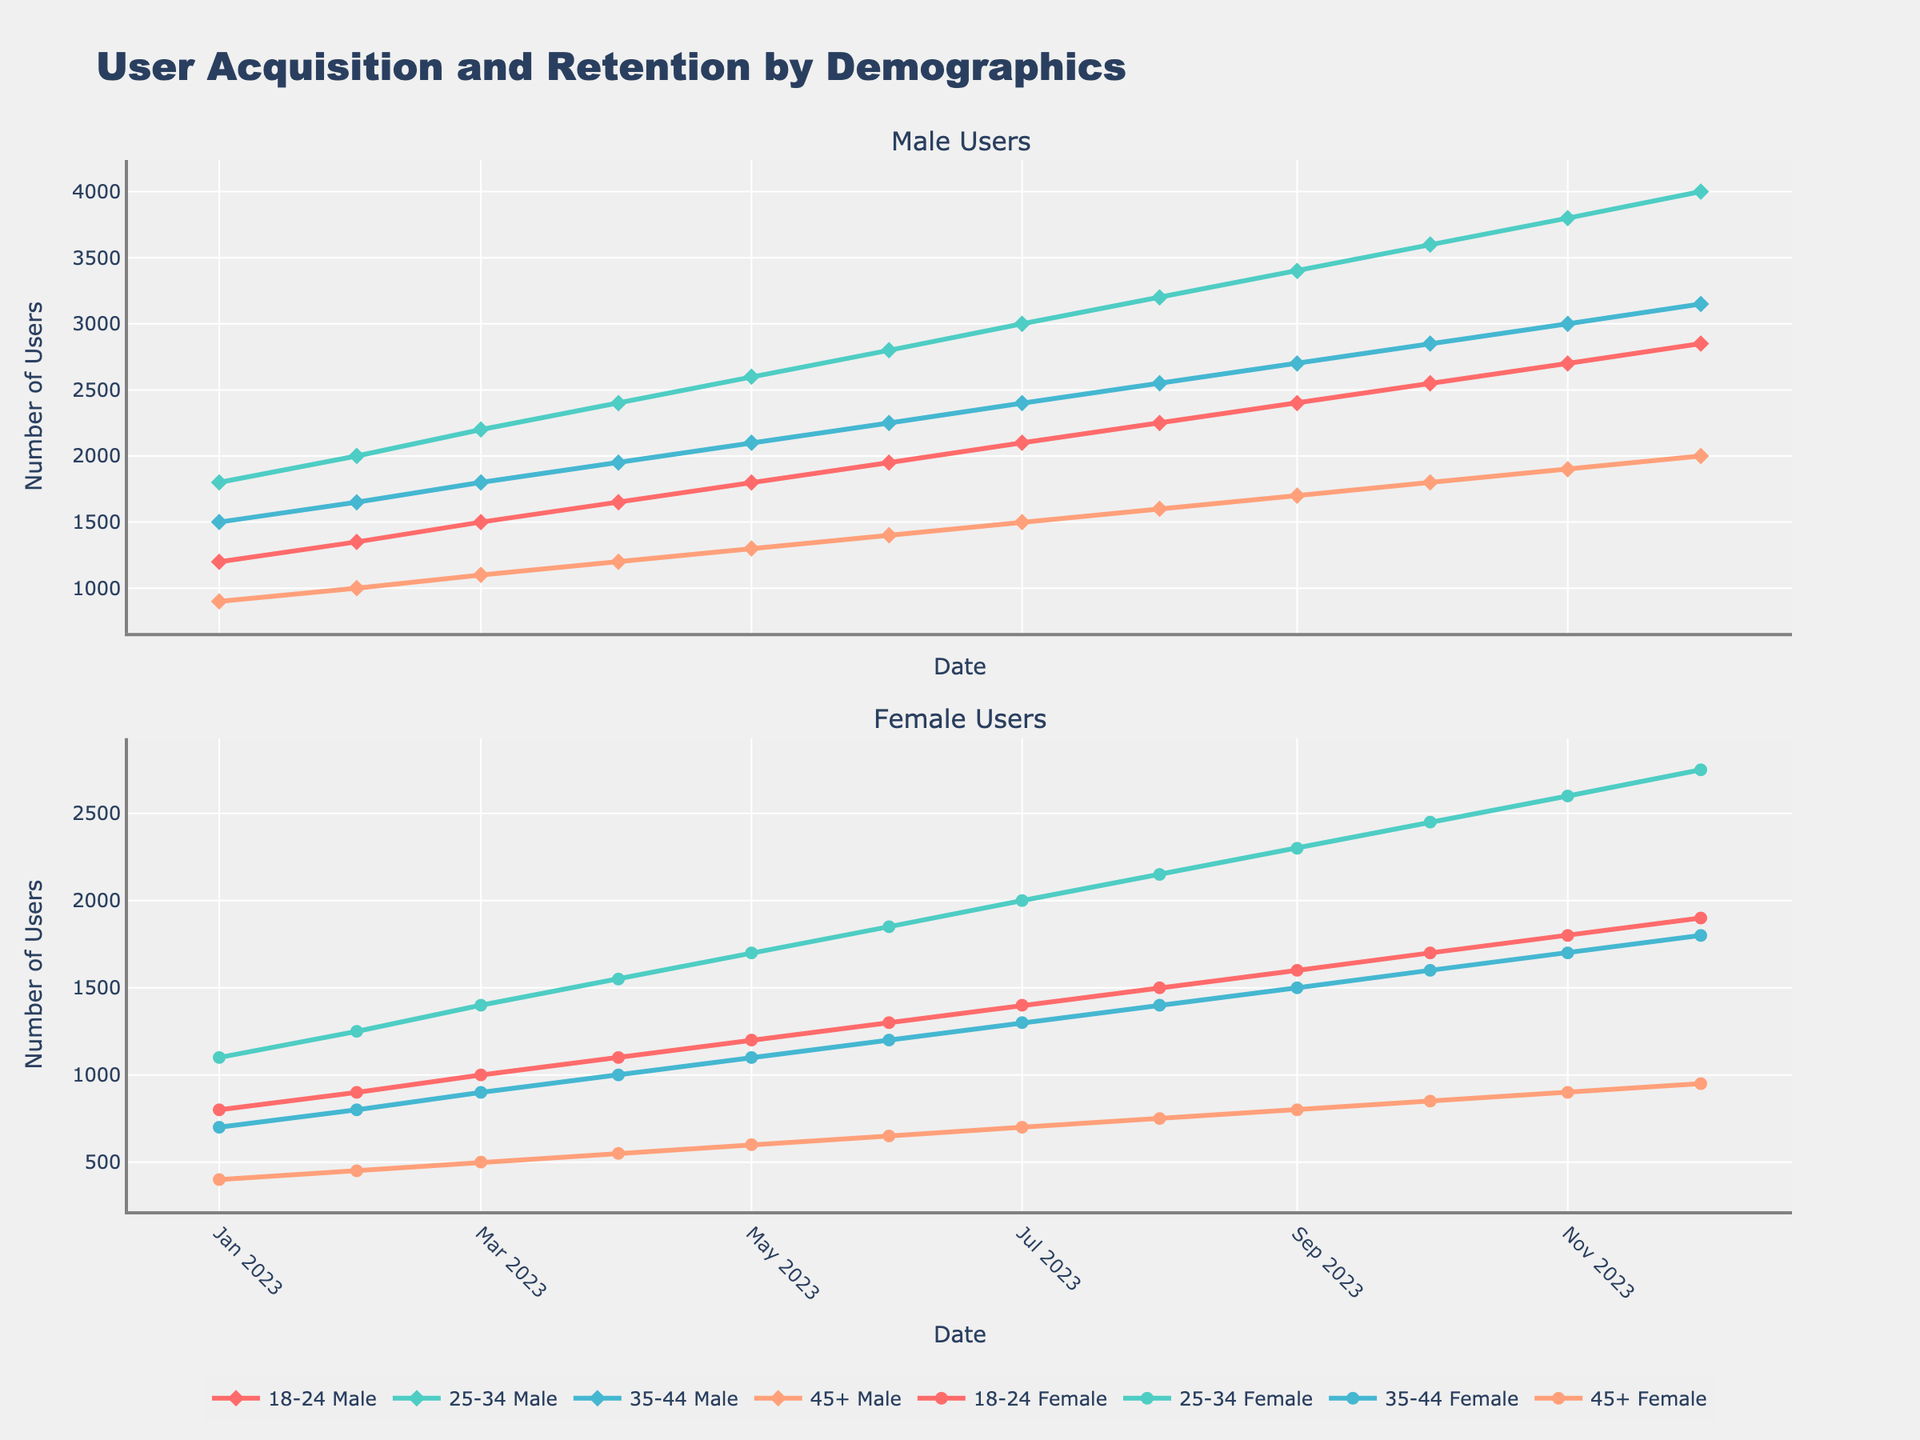What is the total number of male users in January 2023? To calculate the total number of male users in January 2023, sum the values across all age groups for males: \(1200 + 1800 + 1500 + 900 = 5400\)
Answer: 5400 Between August and December 2023, which age group of female users shows the highest increase? To determine which age group of female users has the highest increase, calculate the difference between the values for August and December 2023 for each age group, then identify the highest one. For 18-24: \(1900 - 1500 = 400\), for 25-34: \(2750 - 2150 = 600\), for 35-44: \(1800 - 1400 = 400\), for 45+: \(950 - 750 = 200\). The 25-34 Female group has the highest increase of 600.
Answer: 25-34 Female Which demographic had the highest number of users in December 2023? By examining the data for December 2023, identify the group with the highest value. The values are: 18-24 Male (2850), 25-34 Male (4000), 35-44 Male (3150), 45+ Male (2000), 18-24 Female (1900), 25-34 Female (2750), 35-44 Female (1800), 45+ Female (950). The 25-34 Male group has the highest value at 4000.
Answer: 25-34 Male What is the combined number of users for the 18-24 age groups (both male and female) in June 2023? To find the combined number of users for the 18-24 age group in June 2023, add the values for male and female users: \(1950 + 1300 = 3250\)
Answer: 3250 Which gender saw a larger increase in the 35-44 age group from January to December 2023? Calculate the increase for the 35-44 Male and Female groups from January to December 2023. For males: \(3150 - 1500 = 1650\). For females: \(1800 - 700 = 1100\). The male users saw a larger increase of 1650 compared to 1100 for female users.
Answer: Male How did the number of male users in the 25-34 age group change from April to November 2023? To determine the change, calculate the difference between the values in April and November 2023: \(3800 - 2400 = 1400\). The number of users increased by 1400.
Answer: Increased by 1400 In which month did both male and female 18-24 age groups reach 2100 users combined? Calculate the combined users for each month and find when it reaches 2100. For January, it is \(1200 + 800 = 2000\). For February, it is \(1350 + 900 = 2250\). For March, it is \(1500 + 1000 = 2500\). For April, it is \(1650 + 1100 = 2750\). For May, it is \(1800 + 1200 = 3000\). For June, it is \(1950 + 1300 = 3250\). For July, it is \(2100 + 1400 = 3500\). For August, it is \(2250 + 1500 = 3750\). For September, it is \(2400 + 1600 = 4000\). For October, it is \(2550 + 1700 = 4250\). For November, it is \(2700 + 1800 = 4500\). For December, it is \(2850 + 1900 = 4750\). Thus, no month reached exactly 2100 combined users.
Answer: None By how much did the number of 18-24 female users grow between January and July 2023? To find the growth, calculate the difference between the values in July and January: \(1400 - 800 = 600\). The number of users grew by 600.
Answer: 600 